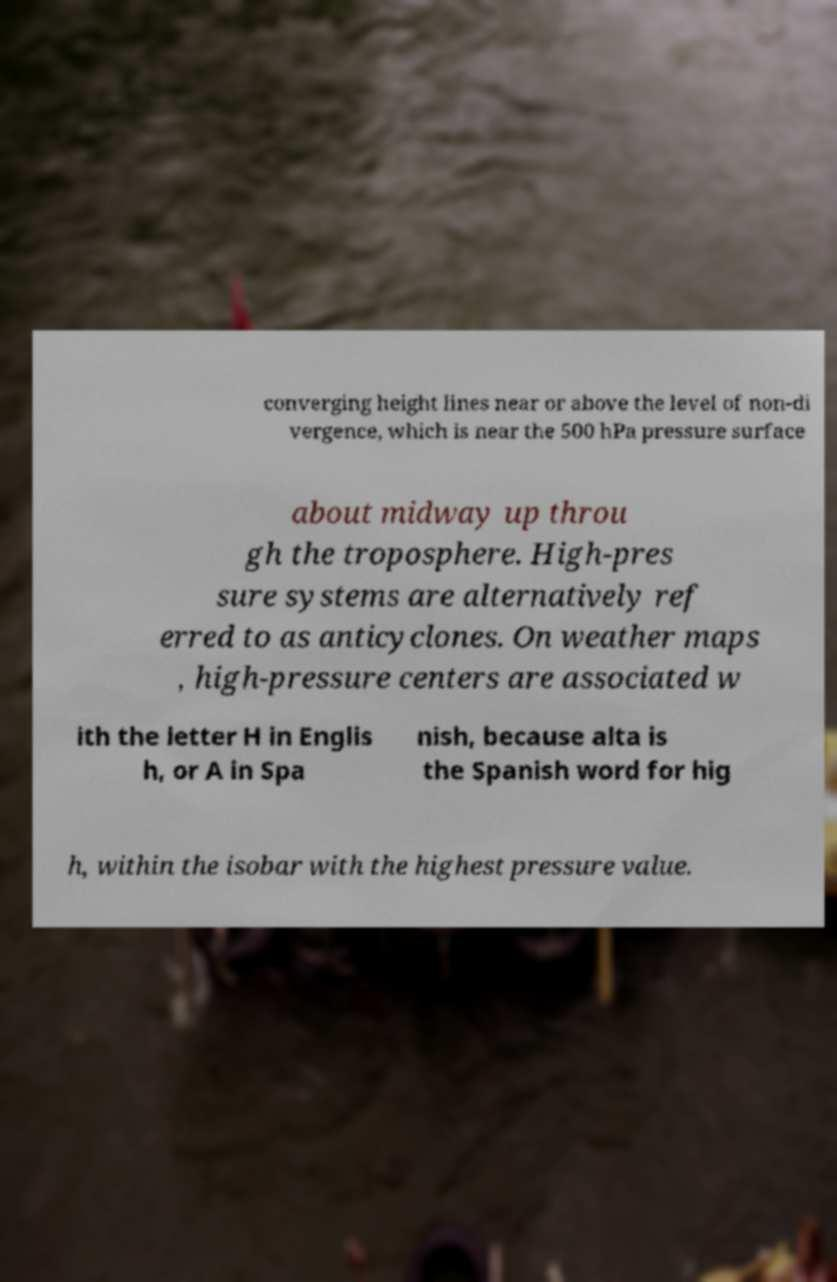There's text embedded in this image that I need extracted. Can you transcribe it verbatim? converging height lines near or above the level of non-di vergence, which is near the 500 hPa pressure surface about midway up throu gh the troposphere. High-pres sure systems are alternatively ref erred to as anticyclones. On weather maps , high-pressure centers are associated w ith the letter H in Englis h, or A in Spa nish, because alta is the Spanish word for hig h, within the isobar with the highest pressure value. 